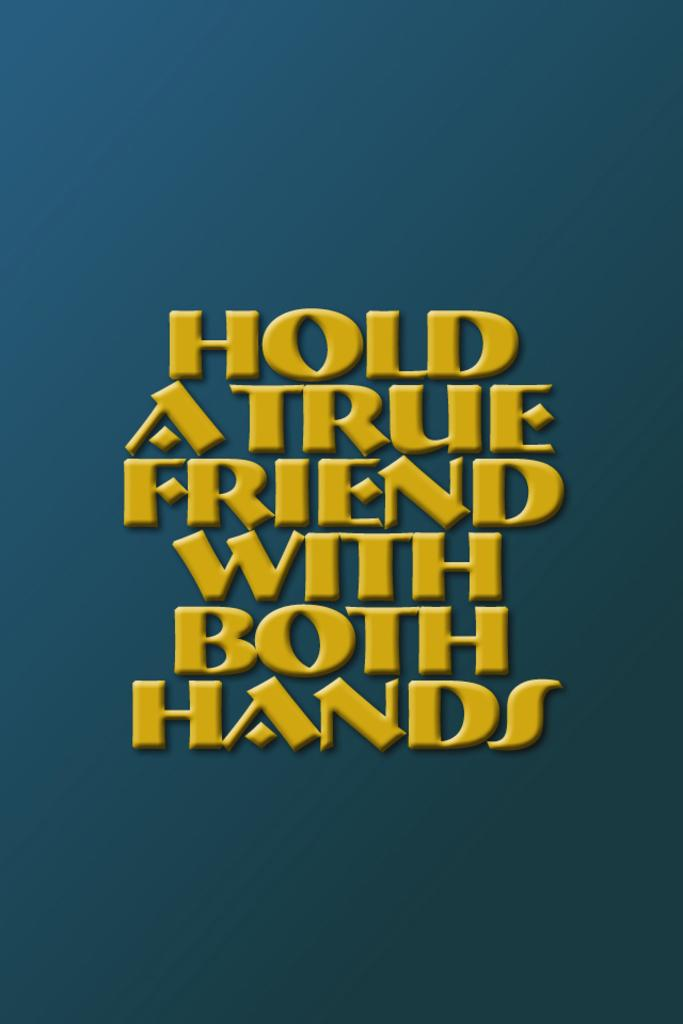<image>
Share a concise interpretation of the image provided. Yellow text tells you to "hold a true friend with both hands." 